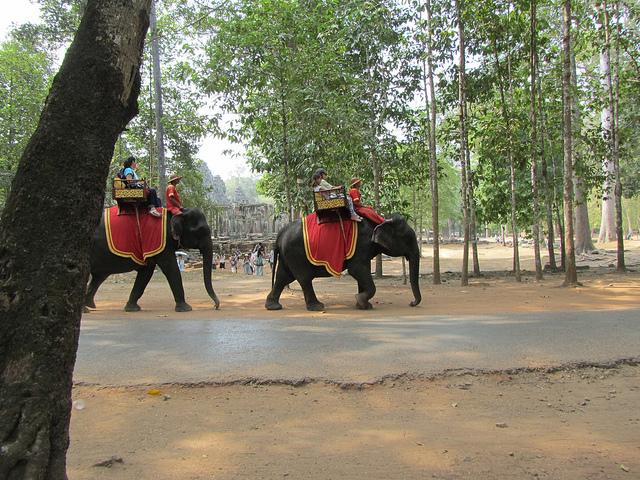Are the animals walking in procession with their trunks and tails linked together?
Quick response, please. No. Is this a jungle or forest area?
Keep it brief. Forest. What kinds of animals are these?
Short answer required. Elephants. Is this entertainment?
Answer briefly. Yes. 